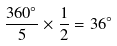<formula> <loc_0><loc_0><loc_500><loc_500>\frac { 3 6 0 ^ { \circ } } { 5 } \times \frac { 1 } { 2 } = 3 6 ^ { \circ }</formula> 